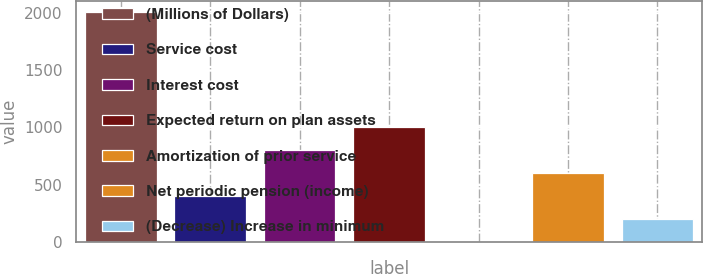<chart> <loc_0><loc_0><loc_500><loc_500><bar_chart><fcel>(Millions of Dollars)<fcel>Service cost<fcel>Interest cost<fcel>Expected return on plan assets<fcel>Amortization of prior service<fcel>Net periodic pension (income)<fcel>(Decrease) Increase in minimum<nl><fcel>2005<fcel>402.2<fcel>802.9<fcel>1003.25<fcel>1.5<fcel>602.55<fcel>201.85<nl></chart> 